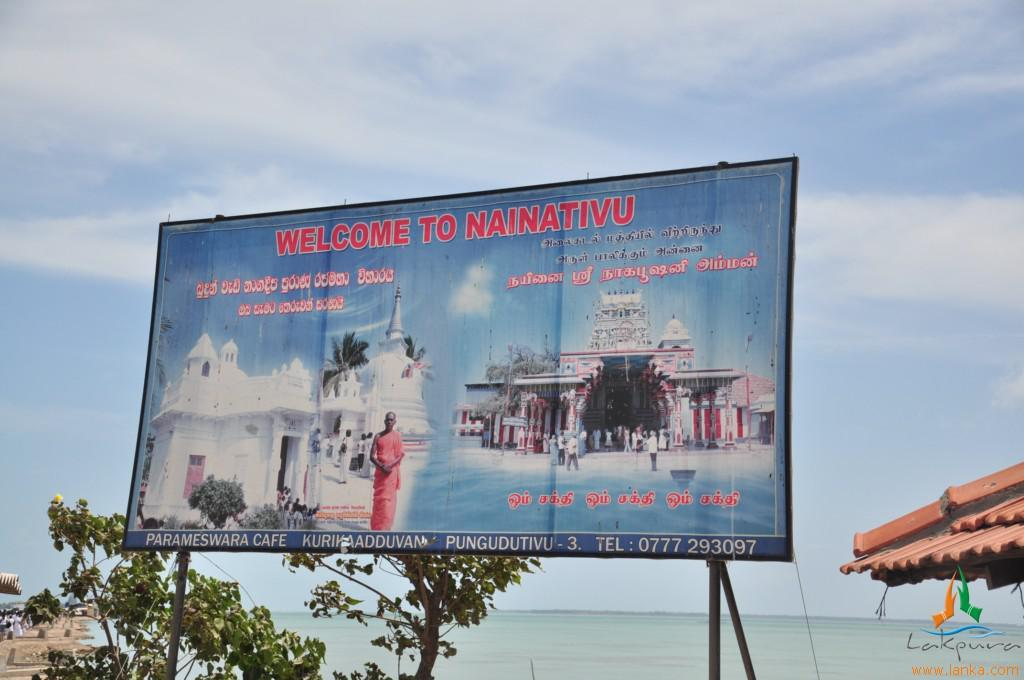<image>
Present a compact description of the photo's key features. A welcome to Nainativu sign shows water and a phone number 